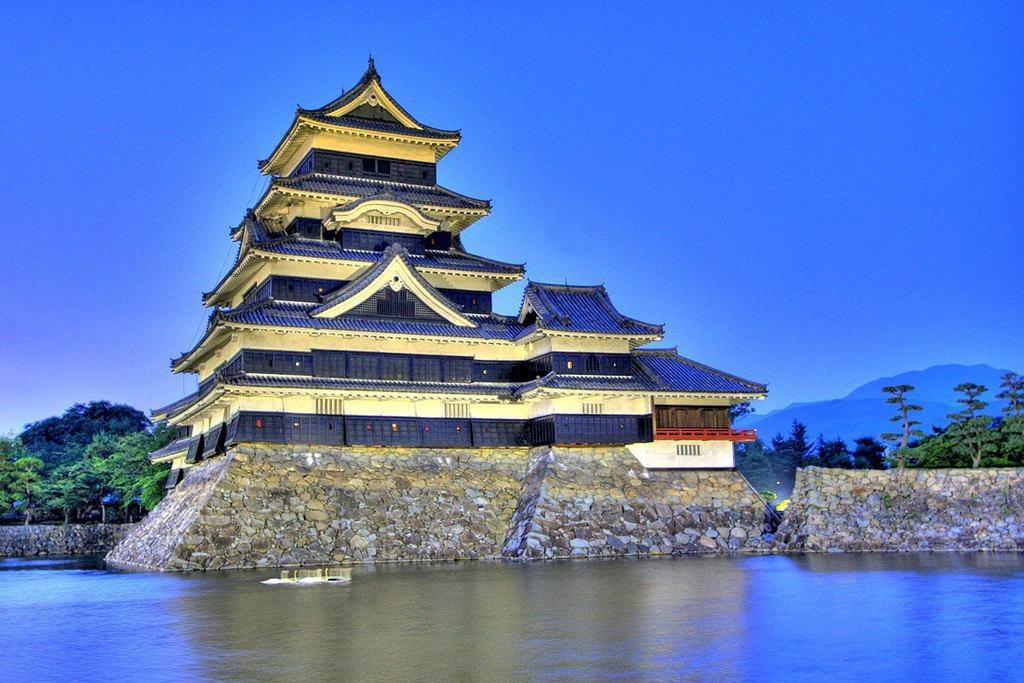How would you summarize this image in a sentence or two? In this image I can see water in the front. In the background I can see a building, number of trees, mountains and the sky. 